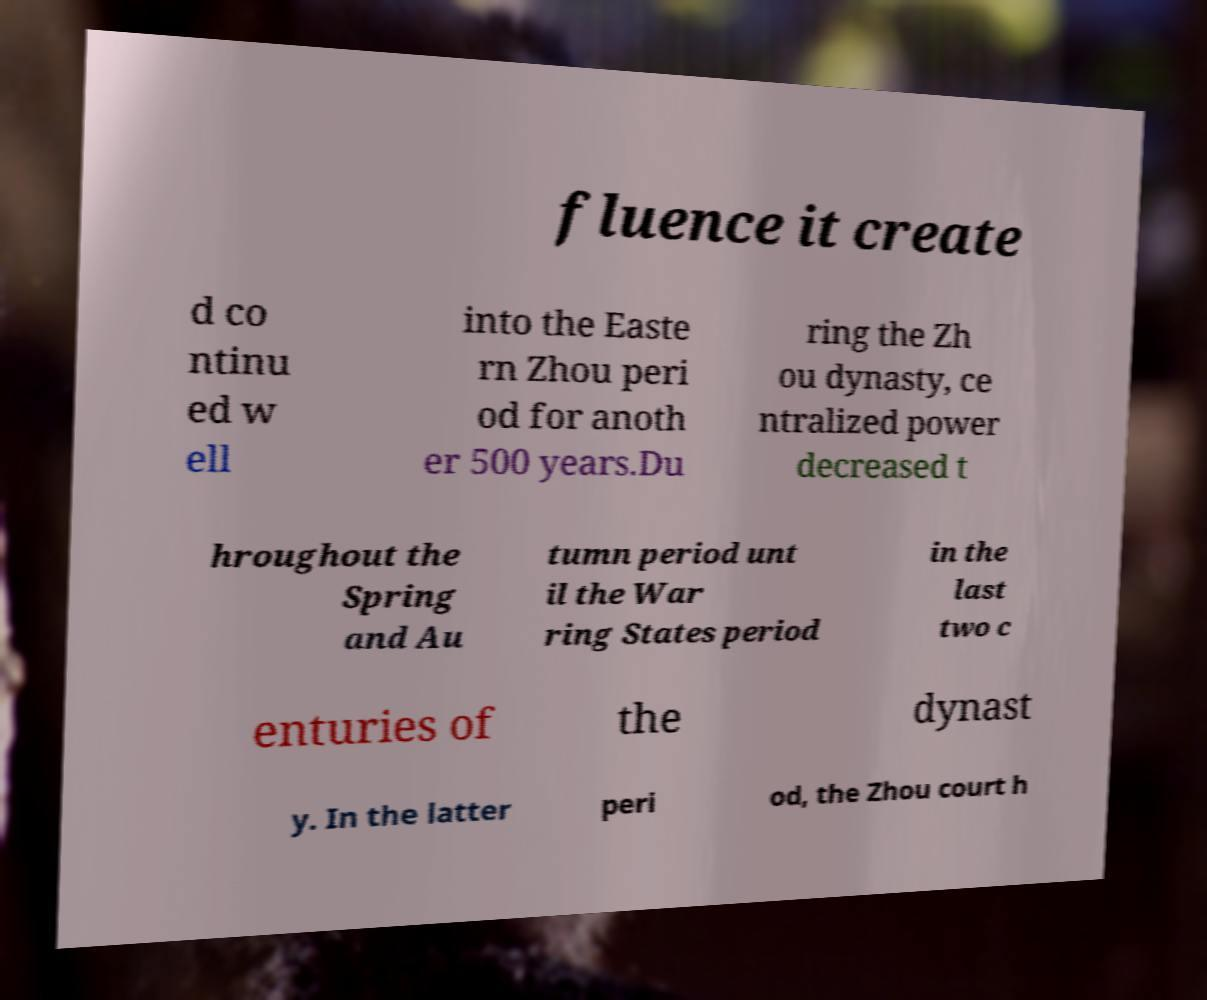I need the written content from this picture converted into text. Can you do that? fluence it create d co ntinu ed w ell into the Easte rn Zhou peri od for anoth er 500 years.Du ring the Zh ou dynasty, ce ntralized power decreased t hroughout the Spring and Au tumn period unt il the War ring States period in the last two c enturies of the dynast y. In the latter peri od, the Zhou court h 